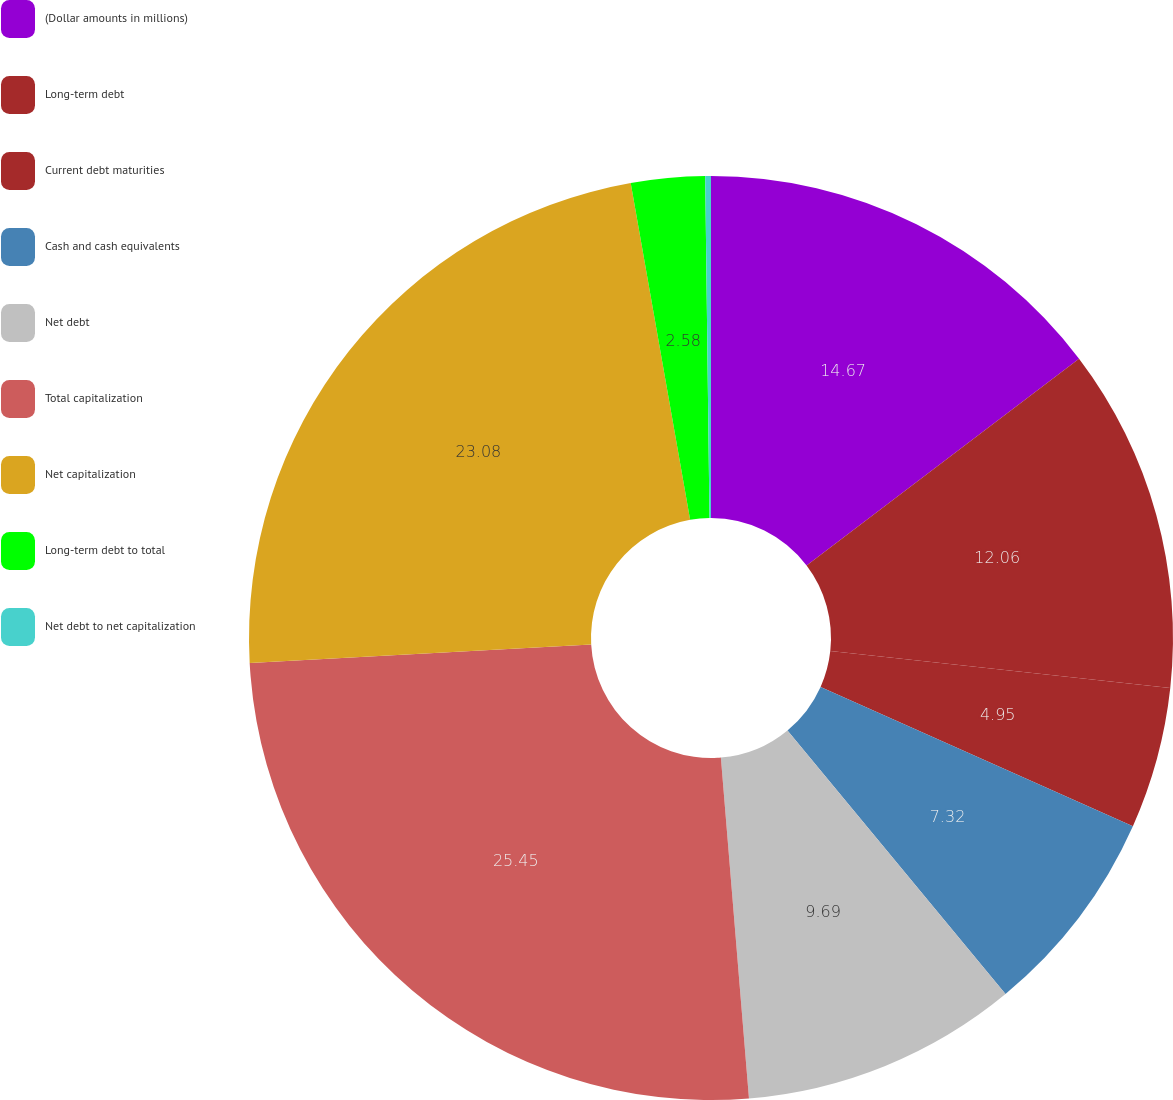<chart> <loc_0><loc_0><loc_500><loc_500><pie_chart><fcel>(Dollar amounts in millions)<fcel>Long-term debt<fcel>Current debt maturities<fcel>Cash and cash equivalents<fcel>Net debt<fcel>Total capitalization<fcel>Net capitalization<fcel>Long-term debt to total<fcel>Net debt to net capitalization<nl><fcel>14.67%<fcel>12.06%<fcel>4.95%<fcel>7.32%<fcel>9.69%<fcel>25.45%<fcel>23.08%<fcel>2.58%<fcel>0.2%<nl></chart> 